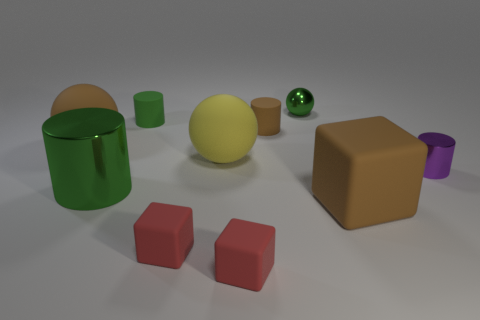Is the number of small blue rubber objects greater than the number of small green rubber cylinders?
Give a very brief answer. No. The metal thing behind the small metal cylinder is what color?
Give a very brief answer. Green. There is a brown matte thing that is to the right of the yellow matte object and behind the tiny metal cylinder; how big is it?
Provide a short and direct response. Small. What number of metal cylinders are the same size as the yellow sphere?
Offer a very short reply. 1. What is the material of the purple thing that is the same shape as the green matte object?
Your response must be concise. Metal. Do the big green metallic object and the purple thing have the same shape?
Give a very brief answer. Yes. There is a small green rubber cylinder; what number of small rubber cubes are on the right side of it?
Your response must be concise. 2. What is the shape of the object on the right side of the big brown object to the right of the large brown rubber sphere?
Your response must be concise. Cylinder. There is a yellow object that is the same material as the big brown cube; what shape is it?
Provide a short and direct response. Sphere. There is a green metal thing to the left of the small green sphere; is its size the same as the brown object in front of the purple metallic object?
Offer a terse response. Yes. 